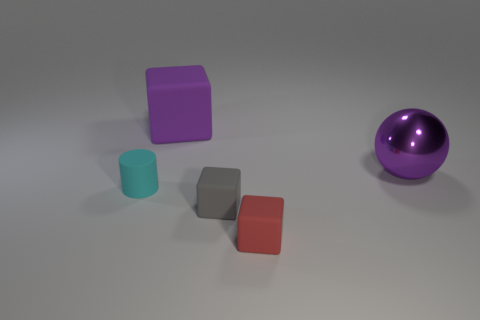Subtract all tiny matte blocks. How many blocks are left? 1 Add 1 tiny green cubes. How many objects exist? 6 Subtract all blocks. How many objects are left? 2 Subtract all balls. Subtract all purple shiny spheres. How many objects are left? 3 Add 5 metallic things. How many metallic things are left? 6 Add 5 purple cubes. How many purple cubes exist? 6 Subtract 1 cyan cylinders. How many objects are left? 4 